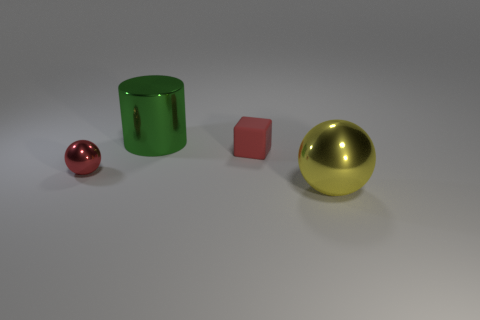What is the shape of the small red object that is to the right of the metal cylinder?
Give a very brief answer. Cube. Is the number of red objects to the left of the small shiny ball less than the number of things that are left of the large sphere?
Provide a short and direct response. Yes. Are the big object that is to the left of the big sphere and the tiny red cube left of the large ball made of the same material?
Make the answer very short. No. What is the shape of the yellow thing?
Offer a terse response. Sphere. Is the number of balls that are behind the large yellow metallic sphere greater than the number of green things right of the small red rubber block?
Your response must be concise. Yes. Is the shape of the small object that is behind the tiny red metallic ball the same as the big shiny object behind the red metal sphere?
Your answer should be very brief. No. How many other objects are the same size as the matte cube?
Offer a terse response. 1. What is the size of the yellow metal ball?
Your answer should be compact. Large. Do the small object that is on the left side of the block and the small block have the same material?
Your answer should be very brief. No. There is another tiny object that is the same shape as the yellow metallic object; what color is it?
Ensure brevity in your answer.  Red. 